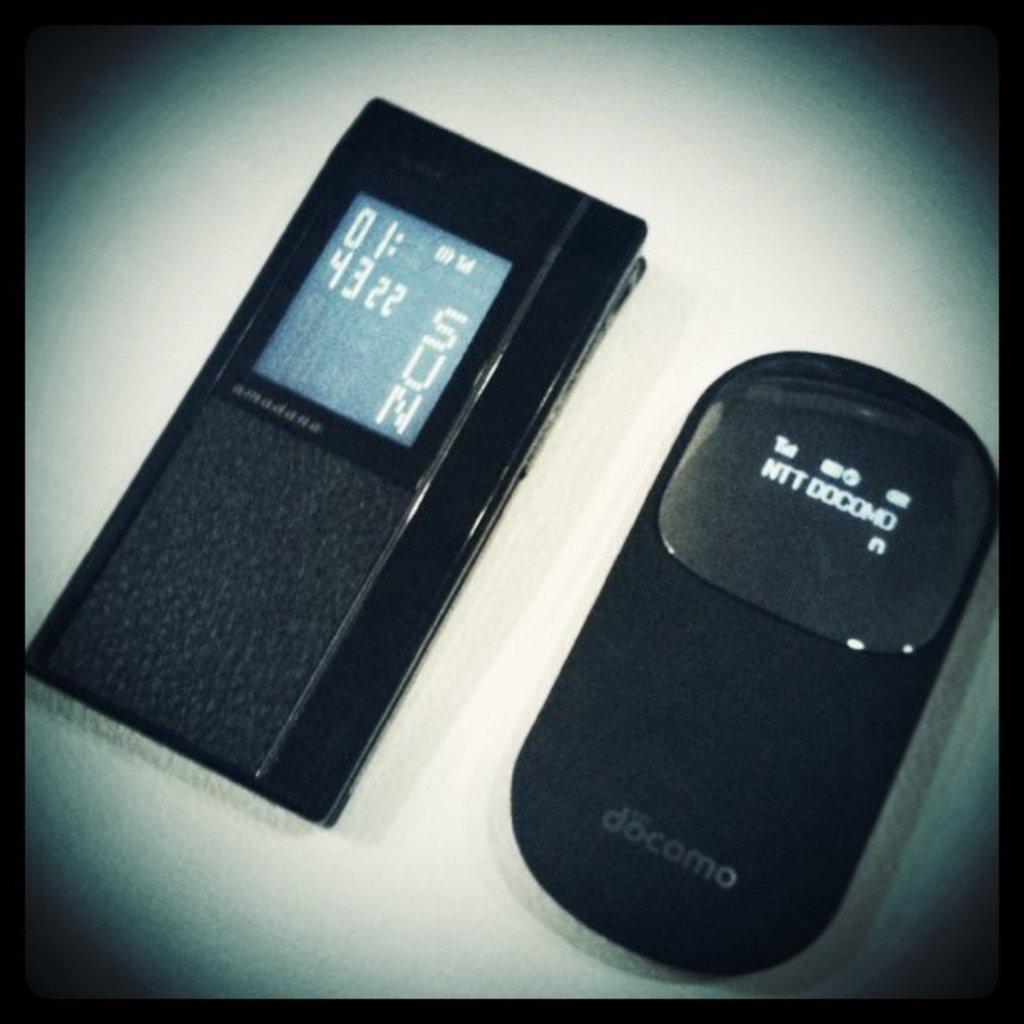What time is it?
Keep it short and to the point. 01:43. What day does the left device say?
Provide a succinct answer. Sun. 